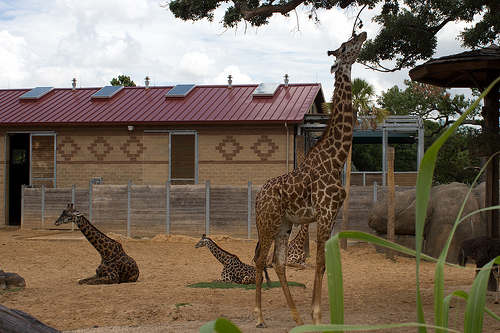Describe the behavior and interaction of the giraffes in the image. In the image, we can see a few giraffes exhibiting different behaviors. One giraffe is standing tall and appears to be alert or looking around, maybe scanning the surroundings. Another giraffe is lying on the ground, probably resting or engaging in social interaction with the giraffe closest to it, which is also lying down. These positions suggest a relaxed environment possibly in a zoo or reserve. Provide a detailed description of the building in the background. The building in the background features a red sloped roof equipped with several solar panels that suggest an environmentally conscious design. The walls of the building have a tan-colored brick pattern with a distinctive diamond design, adding an aesthetic touch. There are windows allowing light inside and a wooden fence attached at the front, likely serving as a barrier for the zoo habitats or enclosures. The overall architecture combines practicality with visual appeal, blending function with a natural theme. 